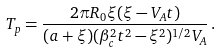<formula> <loc_0><loc_0><loc_500><loc_500>T _ { p } = \frac { 2 \pi R _ { 0 } \xi ( \xi - V _ { A } t ) } { ( a + \xi ) ( \beta ^ { 2 } _ { c } t ^ { 2 } - \xi ^ { 2 } ) ^ { 1 / 2 } V _ { A } } \, .</formula> 